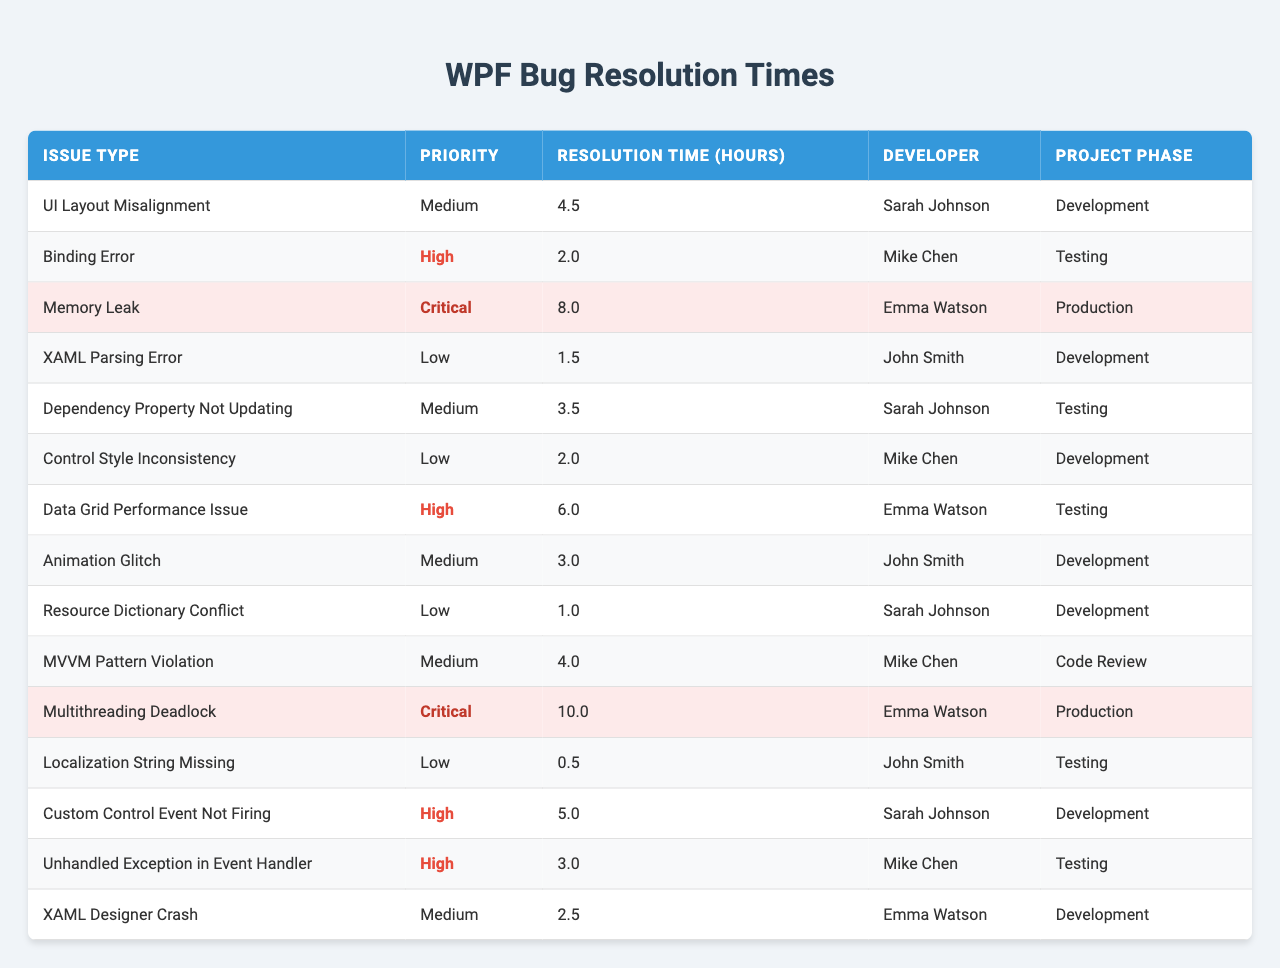What is the longest resolution time for a WPF-related issue? By examining the "Resolution Time (hours)" column, the maximum value is found to be 10.0 hours, which corresponds to the "Multithreading Deadlock" issue.
Answer: 10.0 hours Which developer took the least time to resolve a bug? The "Resolution Time (hours)" for each developer should be compared to identify the lowest. The issue "Localization String Missing" resolved by John Smith took only 0.5 hours.
Answer: John Smith What is the average resolution time for bugs marked as High priority? The High priority issues and their resolution times are 2.0, 6.0, 5.0, and 3.0 hours. Summing these values gives 16.0 hours for 4 issues. The average is 16.0/4 = 4.0 hours.
Answer: 4.0 hours Are there any critical issues resolved by Sarah Johnson? Scanning the table for "Critical" issues associated with Sarah Johnson reveals no entries, thus confirming that there are none.
Answer: No What percentage of the resolved issues are classified as Medium priority? The total number of issues is 15. Medium priority issues are 5 in number. Therefore, the percentage is (5/15) * 100 = 33.33%.
Answer: 33.33% Which project phase had the highest average resolution time? By separating the issue data by phase and calculating the average, the averages are found to be 5.5 hours for Production (2 issues) and 3.65 hours for Development (6 issues). Production has the highest average.
Answer: Production What is the total resolution time for all bugs in the Testing phase? The resolution times for issues in the Testing phase are 2.0, 6.0, 3.0, and 0.5 hours. The total is 2.0 + 6.0 + 3.0 + 0.5 = 11.5 hours.
Answer: 11.5 hours How many issues remain unresolved in the Code Review phase? Referencing the table, it shows there is only one issue ("MVVM Pattern Violation") under Code Review, implying that it is currently under review and thus unresolved.
Answer: 1 Is there any bug type that took longer than 6 hours to resolve? The "Memory Leak" and "Multithreading Deadlock" issues take 8.0 and 10.0 hours, respectively, confirming the presence of bugs exceeding 6 hours in resolution time.
Answer: Yes Which issue took the most time to resolve, and who was the developer? By reviewing the data, "Multithreading Deadlock" took the longest to resolve at 10.0 hours, and the developer responsible was Emma Watson.
Answer: Multithreading Deadlock, Emma Watson 